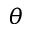Convert formula to latex. <formula><loc_0><loc_0><loc_500><loc_500>\theta</formula> 